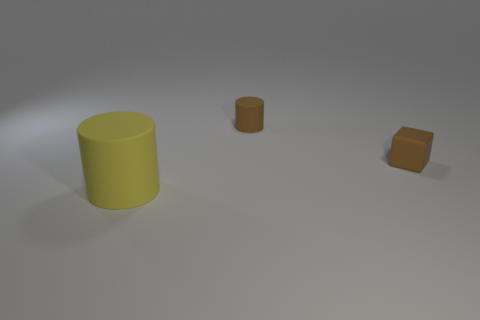Add 1 large brown balls. How many objects exist? 4 Subtract all yellow cylinders. How many cylinders are left? 1 Subtract 0 cyan blocks. How many objects are left? 3 Subtract all cylinders. How many objects are left? 1 Subtract all green cylinders. Subtract all cyan balls. How many cylinders are left? 2 Subtract all small brown metal blocks. Subtract all small cylinders. How many objects are left? 2 Add 1 cubes. How many cubes are left? 2 Add 2 big purple blocks. How many big purple blocks exist? 2 